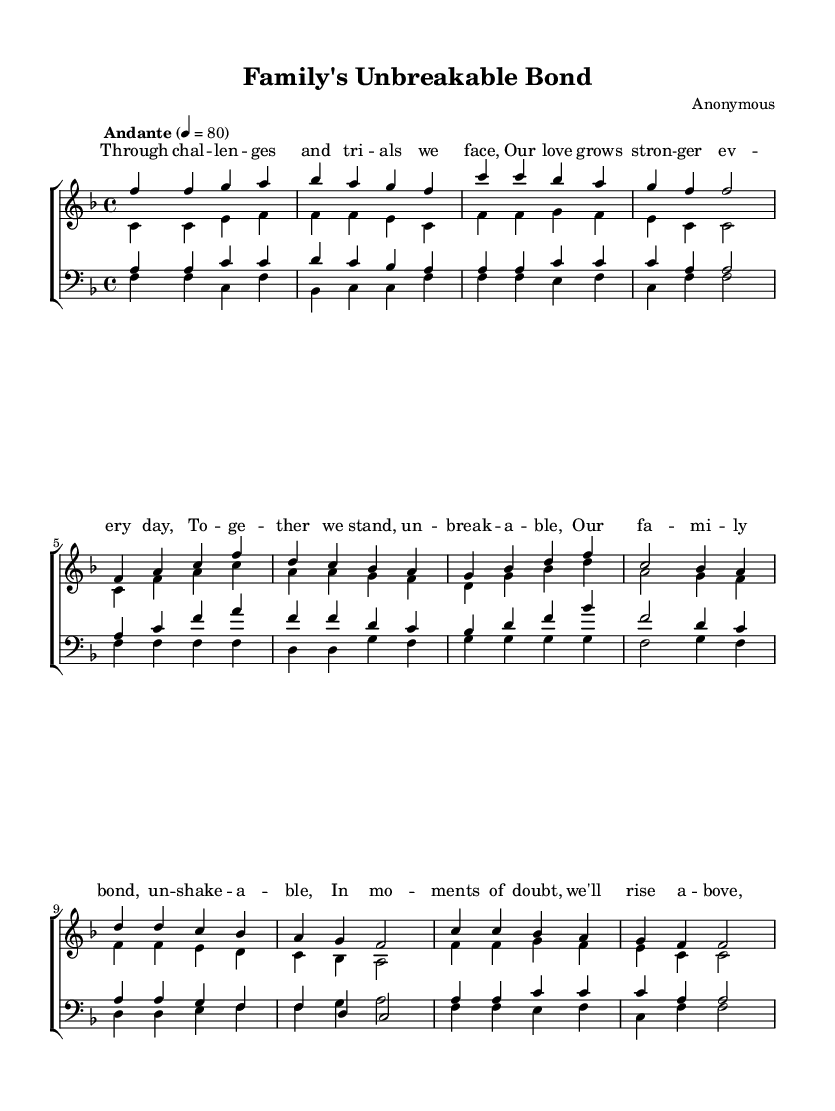What is the key signature of this music? The key signature is F major, which has one flat (B-flat). This can be determined by looking at the key signature symbol placed at the beginning of the staff.
Answer: F major What is the time signature of this piece? The time signature is 4/4, which can be found at the beginning of the score. It indicates that there are four beats per measure and a quarter note gets one beat.
Answer: 4/4 What is the tempo marking for this choral work? The tempo marking is "Andante," which is indicated in the score. This term typically suggests a moderate walking pace, generally around 76-108 beats per minute.
Answer: Andante How many measures are in the chorus section? The chorus section contains four measures, which can be counted by examining the notation and counting each segment of the music that is separated by vertical lines (bar lines).
Answer: Four Which voice has the highest range in the score? The soprano voice has the highest range, as it typically sings the melody in the choral arrangements represented in the upper staff of the score.
Answer: Soprano What theme do the lyrics convey in the bridge section? The lyrics in the bridge section convey themes of hope and support. This can be interpreted from the words that focus on rising above doubt and being guided by love.
Answer: Hope and support How many vocal parts are included in this choral work? The choral work includes four vocal parts: soprano, alto, tenor, and bass. This can be identified by examining the different staves labeled for each voice part.
Answer: Four 